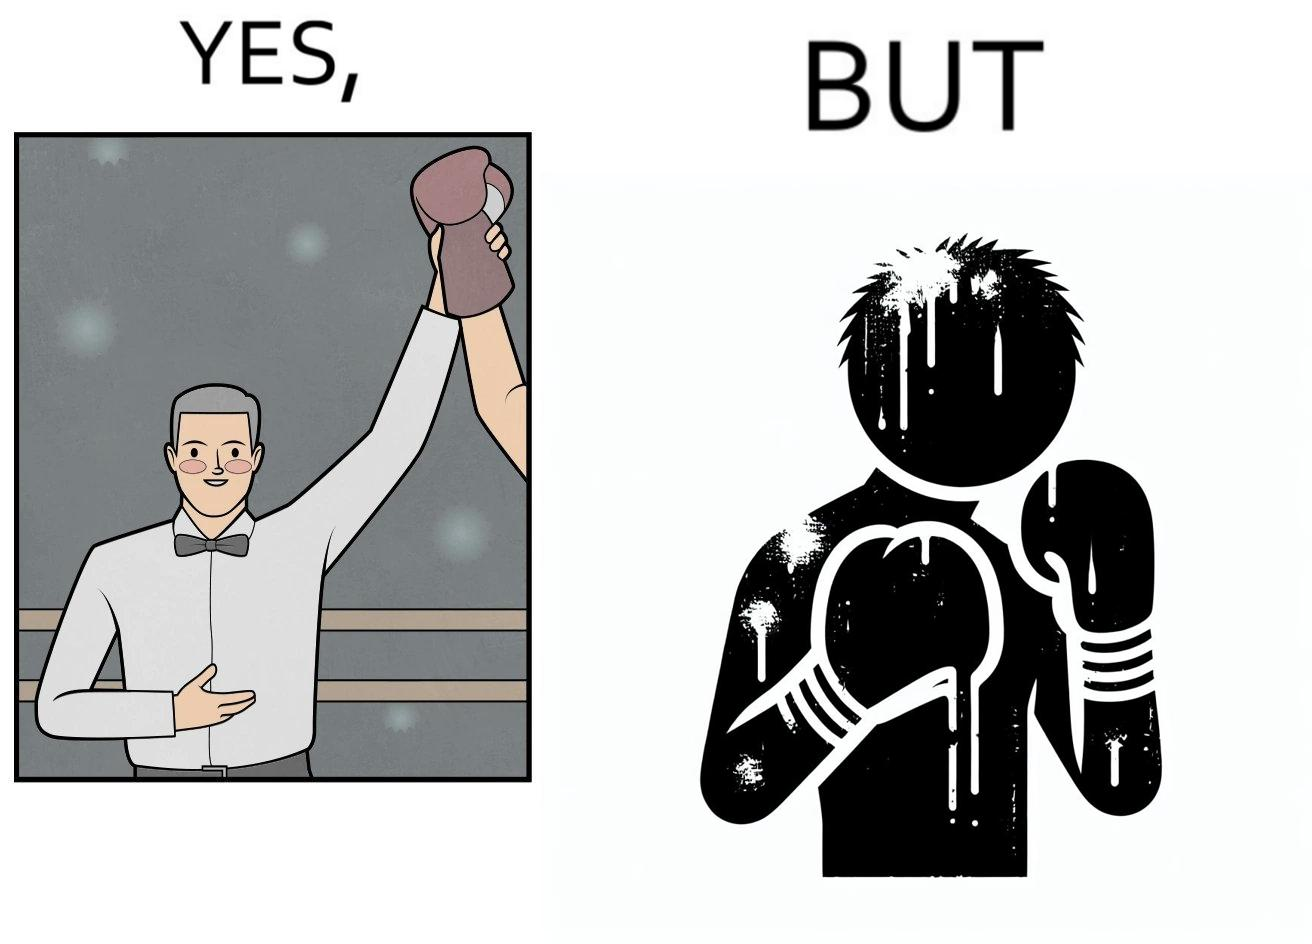Explain why this image is satirical. The image is ironic because even though a boxer has won the match and it is supposed to be a moment of celebration, the boxer got bruised in several places during the match. This is an illustration of what hurdles a person has to go through in order to succeed. 